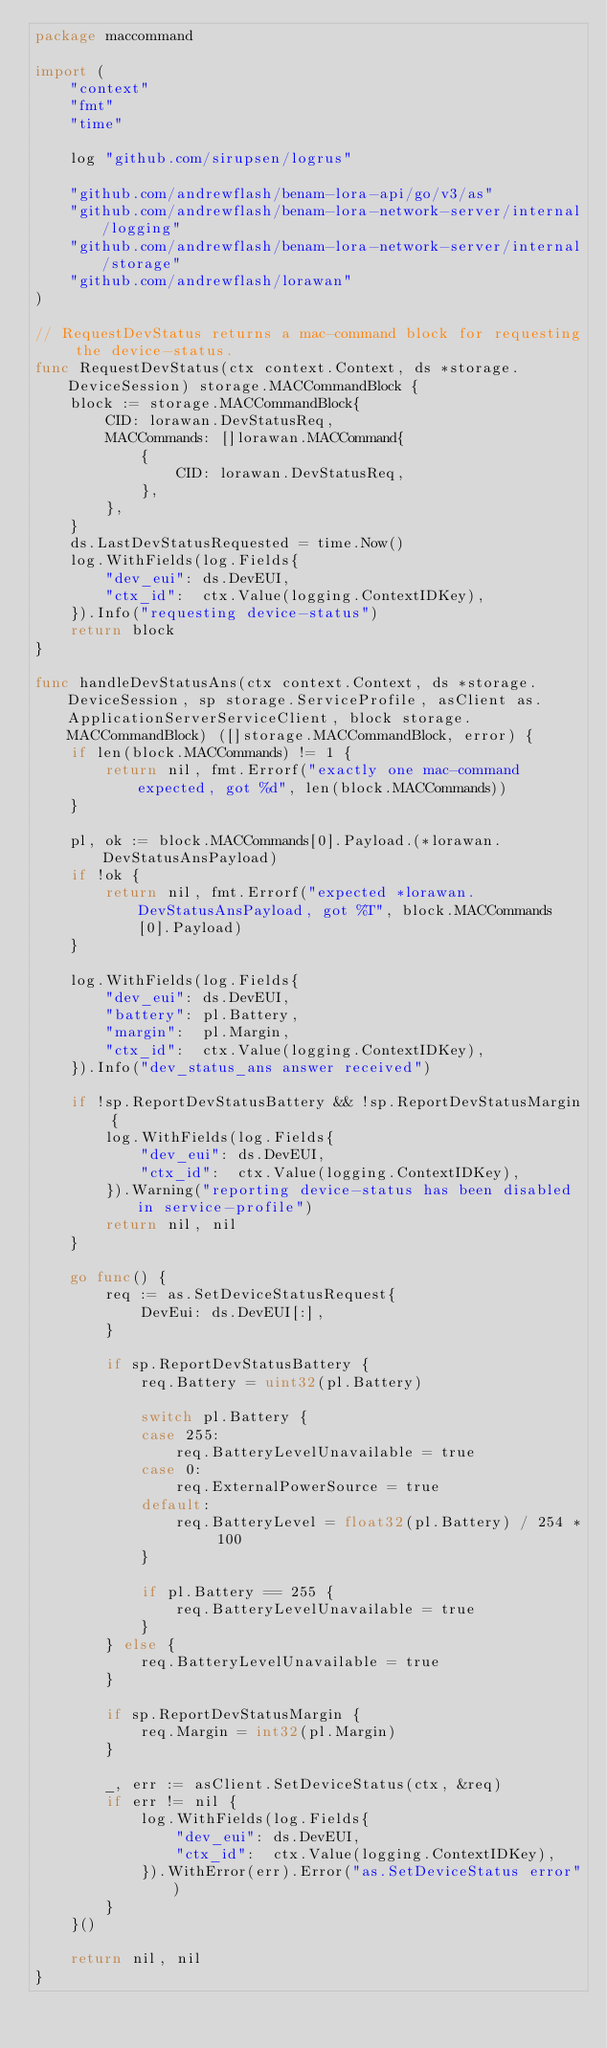<code> <loc_0><loc_0><loc_500><loc_500><_Go_>package maccommand

import (
	"context"
	"fmt"
	"time"

	log "github.com/sirupsen/logrus"

	"github.com/andrewflash/benam-lora-api/go/v3/as"
	"github.com/andrewflash/benam-lora-network-server/internal/logging"
	"github.com/andrewflash/benam-lora-network-server/internal/storage"
	"github.com/andrewflash/lorawan"
)

// RequestDevStatus returns a mac-command block for requesting the device-status.
func RequestDevStatus(ctx context.Context, ds *storage.DeviceSession) storage.MACCommandBlock {
	block := storage.MACCommandBlock{
		CID: lorawan.DevStatusReq,
		MACCommands: []lorawan.MACCommand{
			{
				CID: lorawan.DevStatusReq,
			},
		},
	}
	ds.LastDevStatusRequested = time.Now()
	log.WithFields(log.Fields{
		"dev_eui": ds.DevEUI,
		"ctx_id":  ctx.Value(logging.ContextIDKey),
	}).Info("requesting device-status")
	return block
}

func handleDevStatusAns(ctx context.Context, ds *storage.DeviceSession, sp storage.ServiceProfile, asClient as.ApplicationServerServiceClient, block storage.MACCommandBlock) ([]storage.MACCommandBlock, error) {
	if len(block.MACCommands) != 1 {
		return nil, fmt.Errorf("exactly one mac-command expected, got %d", len(block.MACCommands))
	}

	pl, ok := block.MACCommands[0].Payload.(*lorawan.DevStatusAnsPayload)
	if !ok {
		return nil, fmt.Errorf("expected *lorawan.DevStatusAnsPayload, got %T", block.MACCommands[0].Payload)
	}

	log.WithFields(log.Fields{
		"dev_eui": ds.DevEUI,
		"battery": pl.Battery,
		"margin":  pl.Margin,
		"ctx_id":  ctx.Value(logging.ContextIDKey),
	}).Info("dev_status_ans answer received")

	if !sp.ReportDevStatusBattery && !sp.ReportDevStatusMargin {
		log.WithFields(log.Fields{
			"dev_eui": ds.DevEUI,
			"ctx_id":  ctx.Value(logging.ContextIDKey),
		}).Warning("reporting device-status has been disabled in service-profile")
		return nil, nil
	}

	go func() {
		req := as.SetDeviceStatusRequest{
			DevEui: ds.DevEUI[:],
		}

		if sp.ReportDevStatusBattery {
			req.Battery = uint32(pl.Battery)

			switch pl.Battery {
			case 255:
				req.BatteryLevelUnavailable = true
			case 0:
				req.ExternalPowerSource = true
			default:
				req.BatteryLevel = float32(pl.Battery) / 254 * 100
			}

			if pl.Battery == 255 {
				req.BatteryLevelUnavailable = true
			}
		} else {
			req.BatteryLevelUnavailable = true
		}

		if sp.ReportDevStatusMargin {
			req.Margin = int32(pl.Margin)
		}

		_, err := asClient.SetDeviceStatus(ctx, &req)
		if err != nil {
			log.WithFields(log.Fields{
				"dev_eui": ds.DevEUI,
				"ctx_id":  ctx.Value(logging.ContextIDKey),
			}).WithError(err).Error("as.SetDeviceStatus error")
		}
	}()

	return nil, nil
}
</code> 